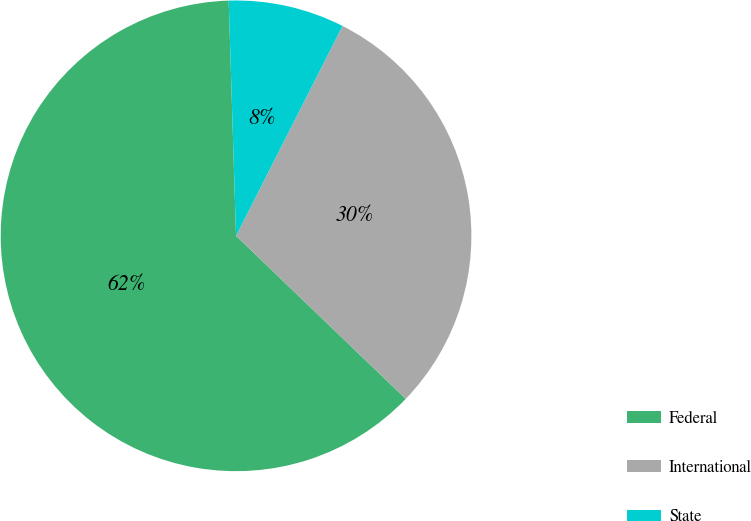Convert chart. <chart><loc_0><loc_0><loc_500><loc_500><pie_chart><fcel>Federal<fcel>International<fcel>State<nl><fcel>62.32%<fcel>29.71%<fcel>7.97%<nl></chart> 